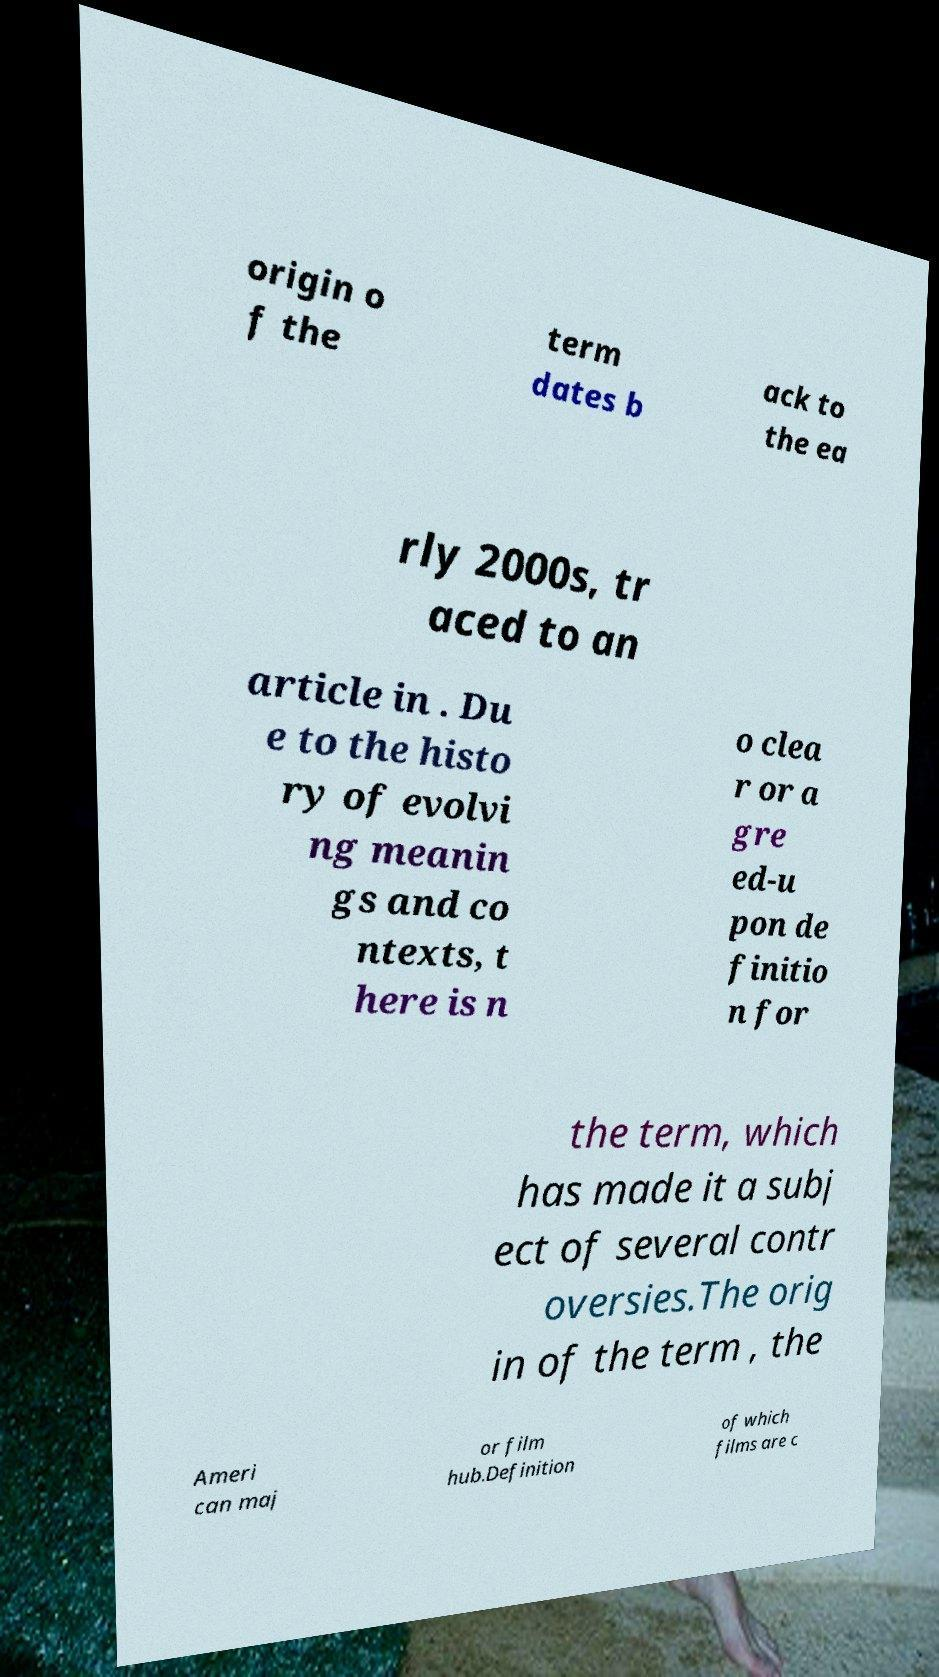I need the written content from this picture converted into text. Can you do that? origin o f the term dates b ack to the ea rly 2000s, tr aced to an article in . Du e to the histo ry of evolvi ng meanin gs and co ntexts, t here is n o clea r or a gre ed-u pon de finitio n for the term, which has made it a subj ect of several contr oversies.The orig in of the term , the Ameri can maj or film hub.Definition of which films are c 